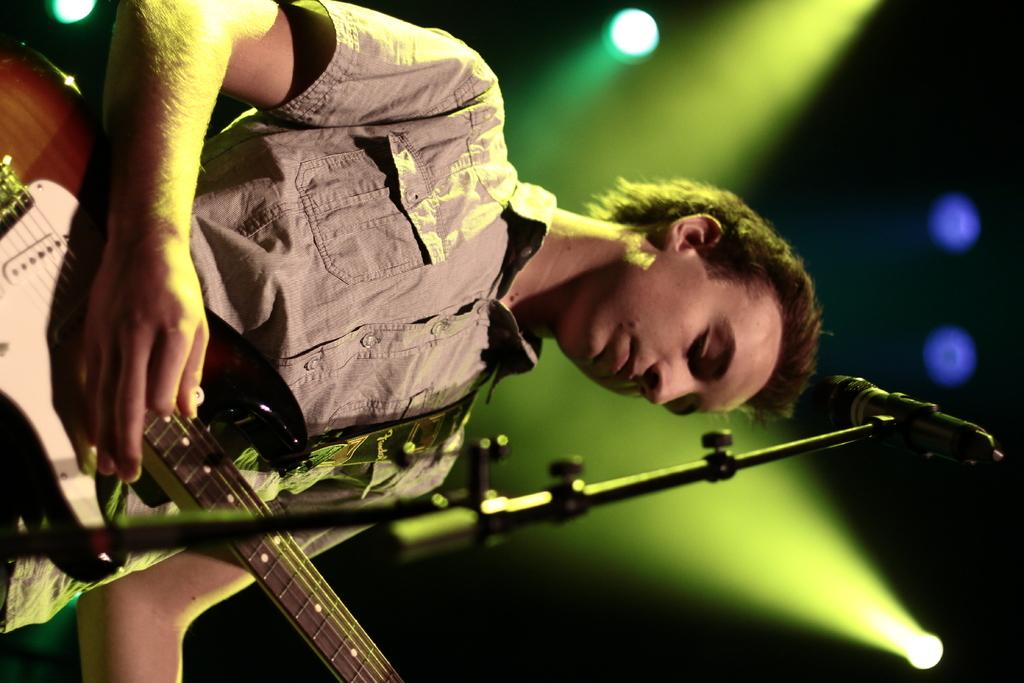What is the man in the image doing? The man is playing the guitar. What is the man standing near in the image? The man is standing in front of a mike stand. What can be seen in the background of the image? There are lights visible in the background of the image. Can you tell me how many volcanoes are visible in the image? There are no volcanoes present in the image. What type of industry is depicted in the image? There is no industry depicted in the image; it features a man playing the guitar in front of a mike stand with lights in the background. 